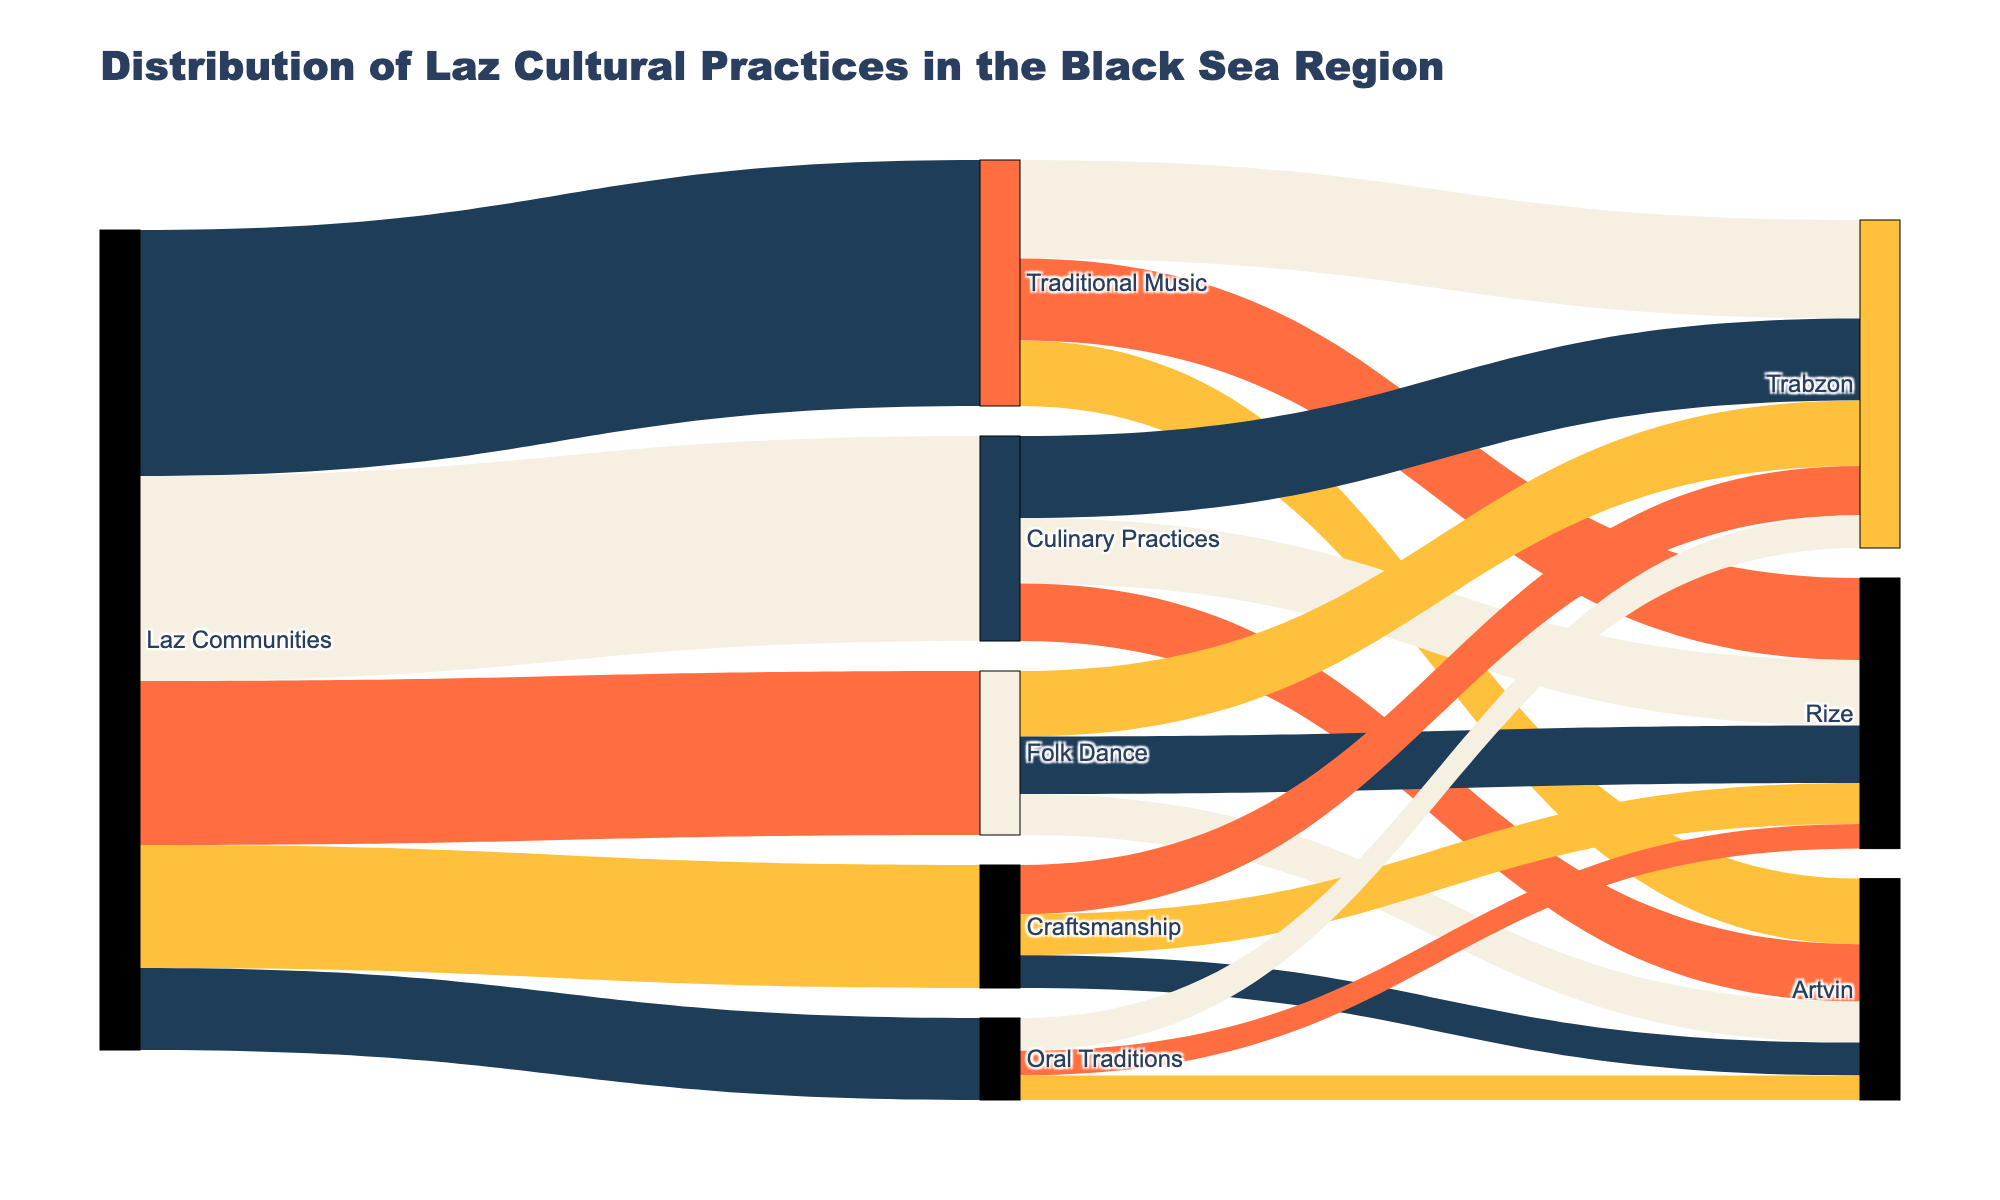What is the title of the Sankey Diagram? The title of the diagram can be found at the top of the figure, usually centralized and in a larger, bold font to stand out as a heading.
Answer: Distribution of Laz Cultural Practices in the Black Sea Region Which Laz cultural practice has the largest distribution value? By looking at the thickness of the Sankey flows originating from Laz Communities towards different practices, the widest one represents the largest value.
Answer: Traditional Music How many values are associated with Traditional Music? Identify the number of flows branching out from Traditional Music to different communities. Count these distinct flows.
Answer: Three What is the total value of Culinary Practices across all communities? Add up all the values connected to Culinary Practices (Trabzon, Rize, Artvin) from the links in the Sankey Diagram.
Answer: 25 Is the value of Folk Dance in Trabzon higher than in Artvin? Compare the values connected to Folk Dance for Trabzon and Artvin. Trabzon is 8 and Artvin is 5.
Answer: Yes What is the combined value of Traditional Music and Culinary Practices in Rize? Sum the individual values linked to Traditional Music and Culinary Practices in Rize. Traditional Music in Rize is 10 and Culinary Practices in Rize is 8. The combined value is 10 + 8.
Answer: 18 Which Laz cultural practice has the smallest representation in Artvin? Compare the values linked to Artvin for each cultural practice. The smallest value among them is the one with the least representation.
Answer: Oral Traditions What is the average distribution value for Craftsmanship among all communities? Add up the values for Craftsmanship across all communities and divide by the number of communities. (6 + 5 + 4) / 3.
Answer: 5 Between Trabzon and Rize, which community has a higher total distribution value for Laz cultural practices? Calculate the total value for each community by summing up all linked values. Trabzon (12 + 10 + 8 + 6 + 4 = 40) and Rize (10 + 8 + 7 + 5 + 3 = 33).
Answer: Trabzon What is the proportion of the value of Traditional Music represented in Trabzon compared to the total value of Traditional Music? Calculate the proportion by dividing the value of Traditional Music in Trabzon by the total value of Traditional Music. 12 / 30.
Answer: 40% 